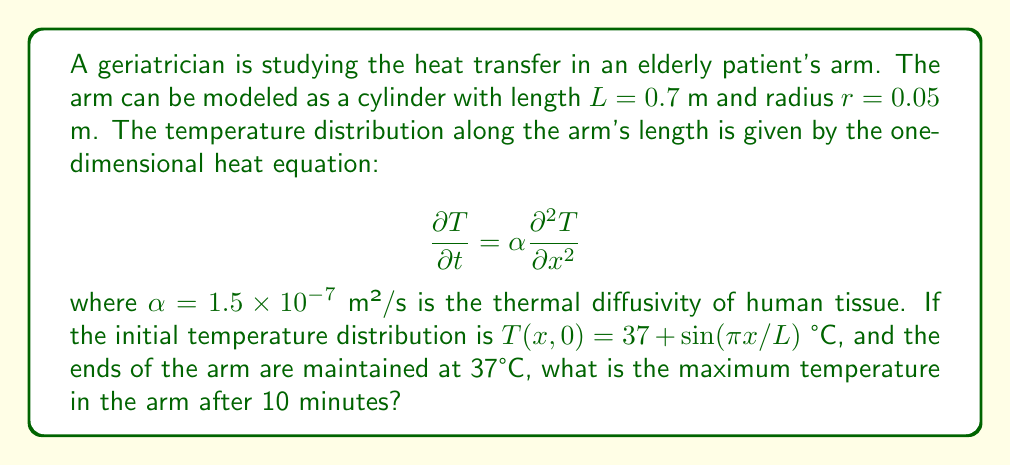Solve this math problem. To solve this problem, we need to use the solution to the one-dimensional heat equation with the given initial and boundary conditions. The solution takes the form:

$$T(x,t) = 37 + \sum_{n=1}^{\infty} B_n \sin\left(\frac{n\pi x}{L}\right)e^{-\alpha\left(\frac{n\pi}{L}\right)^2t}$$

where $B_n$ are the Fourier coefficients.

Given the initial condition $T(x,0) = 37 + \sin(\pi x/L)$, we can see that only the first term of the series is non-zero, with $B_1 = 1$ and $B_n = 0$ for $n > 1$.

Therefore, the solution simplifies to:

$$T(x,t) = 37 + \sin\left(\frac{\pi x}{L}\right)e^{-\alpha\left(\frac{\pi}{L}\right)^2t}$$

To find the maximum temperature after 10 minutes (600 seconds), we need to:

1. Substitute the given values: $L = 0.7$ m, $\alpha = 1.5 \times 10^{-7}$ m²/s, $t = 600$ s
2. Calculate the exponential term:
   $$e^{-\alpha\left(\frac{\pi}{L}\right)^2t} = e^{-(1.5 \times 10^{-7})\left(\frac{\pi}{0.7}\right)^2(600)} \approx 0.5595$$
3. The maximum temperature occurs where $\sin(\pi x/L) = 1$, i.e., at $x = L/2$
4. Calculate the maximum temperature:
   $$T_{max} = 37 + 1 \times 0.5595 = 37.5595°C$$
Answer: 37.5595°C 